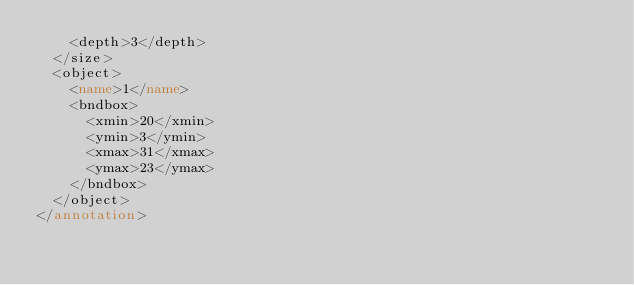<code> <loc_0><loc_0><loc_500><loc_500><_XML_>    <depth>3</depth>
  </size>
  <object>
    <name>1</name>
    <bndbox>
      <xmin>20</xmin>
      <ymin>3</ymin>
      <xmax>31</xmax>
      <ymax>23</ymax>
    </bndbox>
  </object>
</annotation>
</code> 